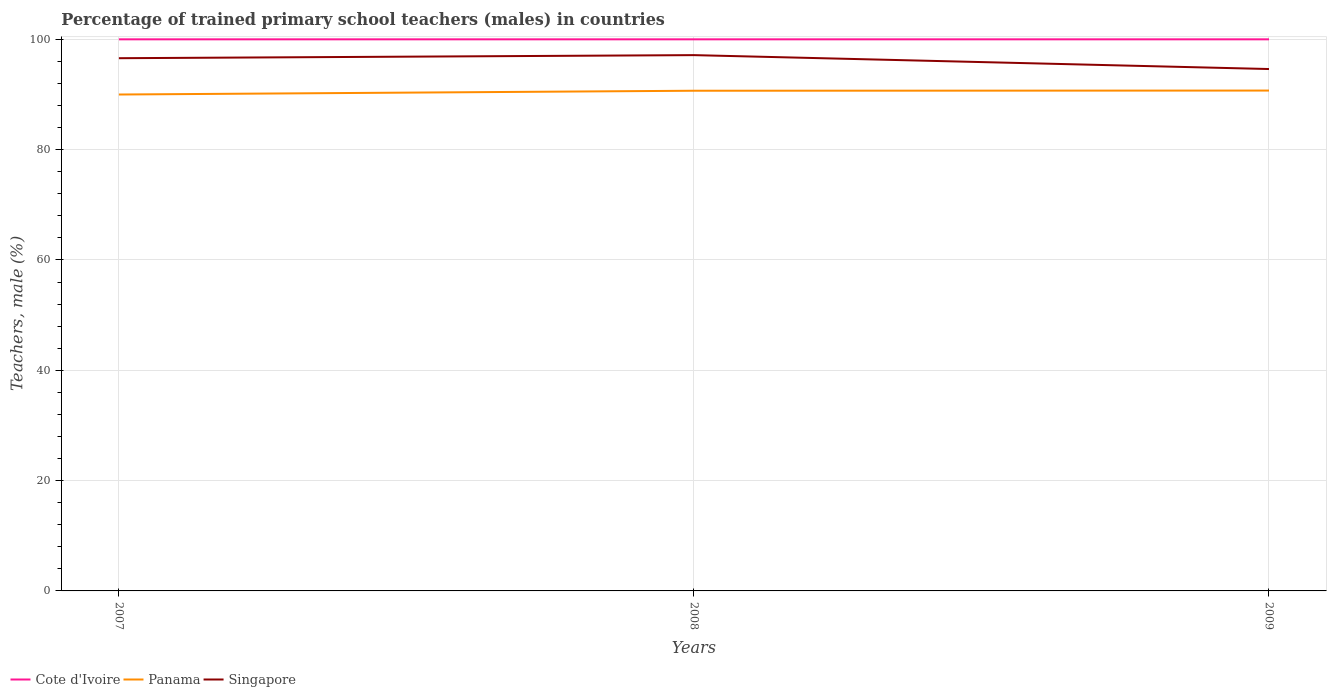How many different coloured lines are there?
Your answer should be compact. 3. Across all years, what is the maximum percentage of trained primary school teachers (males) in Singapore?
Your response must be concise. 94.61. What is the total percentage of trained primary school teachers (males) in Singapore in the graph?
Your answer should be very brief. 2.52. What is the difference between the highest and the second highest percentage of trained primary school teachers (males) in Singapore?
Provide a succinct answer. 2.52. Does the graph contain any zero values?
Offer a very short reply. No. Where does the legend appear in the graph?
Provide a succinct answer. Bottom left. How many legend labels are there?
Provide a short and direct response. 3. How are the legend labels stacked?
Make the answer very short. Horizontal. What is the title of the graph?
Give a very brief answer. Percentage of trained primary school teachers (males) in countries. What is the label or title of the X-axis?
Give a very brief answer. Years. What is the label or title of the Y-axis?
Provide a succinct answer. Teachers, male (%). What is the Teachers, male (%) of Panama in 2007?
Offer a terse response. 90. What is the Teachers, male (%) of Singapore in 2007?
Provide a short and direct response. 96.58. What is the Teachers, male (%) in Cote d'Ivoire in 2008?
Give a very brief answer. 100. What is the Teachers, male (%) in Panama in 2008?
Provide a short and direct response. 90.68. What is the Teachers, male (%) in Singapore in 2008?
Your answer should be very brief. 97.14. What is the Teachers, male (%) of Cote d'Ivoire in 2009?
Your answer should be compact. 100. What is the Teachers, male (%) of Panama in 2009?
Give a very brief answer. 90.71. What is the Teachers, male (%) of Singapore in 2009?
Your response must be concise. 94.61. Across all years, what is the maximum Teachers, male (%) in Cote d'Ivoire?
Your answer should be very brief. 100. Across all years, what is the maximum Teachers, male (%) in Panama?
Ensure brevity in your answer.  90.71. Across all years, what is the maximum Teachers, male (%) in Singapore?
Ensure brevity in your answer.  97.14. Across all years, what is the minimum Teachers, male (%) of Cote d'Ivoire?
Your answer should be compact. 100. Across all years, what is the minimum Teachers, male (%) of Panama?
Offer a very short reply. 90. Across all years, what is the minimum Teachers, male (%) of Singapore?
Your response must be concise. 94.61. What is the total Teachers, male (%) of Cote d'Ivoire in the graph?
Provide a short and direct response. 300. What is the total Teachers, male (%) in Panama in the graph?
Your answer should be compact. 271.39. What is the total Teachers, male (%) of Singapore in the graph?
Keep it short and to the point. 288.33. What is the difference between the Teachers, male (%) in Panama in 2007 and that in 2008?
Provide a short and direct response. -0.69. What is the difference between the Teachers, male (%) in Singapore in 2007 and that in 2008?
Make the answer very short. -0.56. What is the difference between the Teachers, male (%) of Panama in 2007 and that in 2009?
Provide a short and direct response. -0.72. What is the difference between the Teachers, male (%) of Singapore in 2007 and that in 2009?
Your response must be concise. 1.96. What is the difference between the Teachers, male (%) of Panama in 2008 and that in 2009?
Offer a very short reply. -0.03. What is the difference between the Teachers, male (%) in Singapore in 2008 and that in 2009?
Your response must be concise. 2.52. What is the difference between the Teachers, male (%) of Cote d'Ivoire in 2007 and the Teachers, male (%) of Panama in 2008?
Provide a succinct answer. 9.32. What is the difference between the Teachers, male (%) of Cote d'Ivoire in 2007 and the Teachers, male (%) of Singapore in 2008?
Offer a terse response. 2.86. What is the difference between the Teachers, male (%) in Panama in 2007 and the Teachers, male (%) in Singapore in 2008?
Provide a succinct answer. -7.14. What is the difference between the Teachers, male (%) in Cote d'Ivoire in 2007 and the Teachers, male (%) in Panama in 2009?
Offer a terse response. 9.29. What is the difference between the Teachers, male (%) of Cote d'Ivoire in 2007 and the Teachers, male (%) of Singapore in 2009?
Offer a terse response. 5.39. What is the difference between the Teachers, male (%) of Panama in 2007 and the Teachers, male (%) of Singapore in 2009?
Give a very brief answer. -4.62. What is the difference between the Teachers, male (%) in Cote d'Ivoire in 2008 and the Teachers, male (%) in Panama in 2009?
Offer a terse response. 9.29. What is the difference between the Teachers, male (%) in Cote d'Ivoire in 2008 and the Teachers, male (%) in Singapore in 2009?
Your answer should be compact. 5.39. What is the difference between the Teachers, male (%) in Panama in 2008 and the Teachers, male (%) in Singapore in 2009?
Give a very brief answer. -3.93. What is the average Teachers, male (%) of Cote d'Ivoire per year?
Your response must be concise. 100. What is the average Teachers, male (%) of Panama per year?
Ensure brevity in your answer.  90.46. What is the average Teachers, male (%) in Singapore per year?
Your answer should be compact. 96.11. In the year 2007, what is the difference between the Teachers, male (%) of Cote d'Ivoire and Teachers, male (%) of Panama?
Offer a very short reply. 10. In the year 2007, what is the difference between the Teachers, male (%) of Cote d'Ivoire and Teachers, male (%) of Singapore?
Ensure brevity in your answer.  3.42. In the year 2007, what is the difference between the Teachers, male (%) in Panama and Teachers, male (%) in Singapore?
Provide a succinct answer. -6.58. In the year 2008, what is the difference between the Teachers, male (%) of Cote d'Ivoire and Teachers, male (%) of Panama?
Make the answer very short. 9.32. In the year 2008, what is the difference between the Teachers, male (%) in Cote d'Ivoire and Teachers, male (%) in Singapore?
Provide a short and direct response. 2.86. In the year 2008, what is the difference between the Teachers, male (%) of Panama and Teachers, male (%) of Singapore?
Your response must be concise. -6.46. In the year 2009, what is the difference between the Teachers, male (%) of Cote d'Ivoire and Teachers, male (%) of Panama?
Make the answer very short. 9.29. In the year 2009, what is the difference between the Teachers, male (%) in Cote d'Ivoire and Teachers, male (%) in Singapore?
Your response must be concise. 5.39. In the year 2009, what is the difference between the Teachers, male (%) of Panama and Teachers, male (%) of Singapore?
Your answer should be compact. -3.9. What is the ratio of the Teachers, male (%) in Panama in 2007 to that in 2008?
Give a very brief answer. 0.99. What is the ratio of the Teachers, male (%) in Singapore in 2007 to that in 2008?
Your response must be concise. 0.99. What is the ratio of the Teachers, male (%) of Cote d'Ivoire in 2007 to that in 2009?
Provide a short and direct response. 1. What is the ratio of the Teachers, male (%) in Singapore in 2007 to that in 2009?
Offer a terse response. 1.02. What is the ratio of the Teachers, male (%) of Singapore in 2008 to that in 2009?
Provide a succinct answer. 1.03. What is the difference between the highest and the second highest Teachers, male (%) of Panama?
Your answer should be very brief. 0.03. What is the difference between the highest and the second highest Teachers, male (%) of Singapore?
Ensure brevity in your answer.  0.56. What is the difference between the highest and the lowest Teachers, male (%) of Cote d'Ivoire?
Keep it short and to the point. 0. What is the difference between the highest and the lowest Teachers, male (%) in Panama?
Your answer should be very brief. 0.72. What is the difference between the highest and the lowest Teachers, male (%) in Singapore?
Make the answer very short. 2.52. 